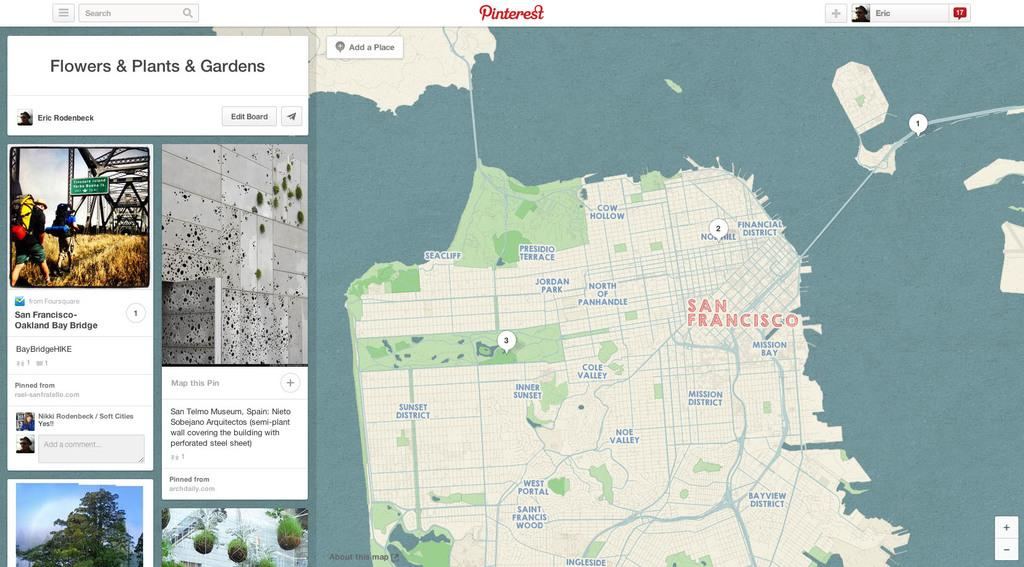What can be seen on the right side of the image? There is a geographical map on the right side of the image. What is located on the left side of the image? There are pictures and information on the left side of the image. Can you tell me how many roses are depicted on the geographical map? There are no roses depicted on the geographical map; it is a map showing geographical features and locations. Is there a person visible in the image? The provided facts do not mention a person being present in the image, so we cannot definitively answer that question. 